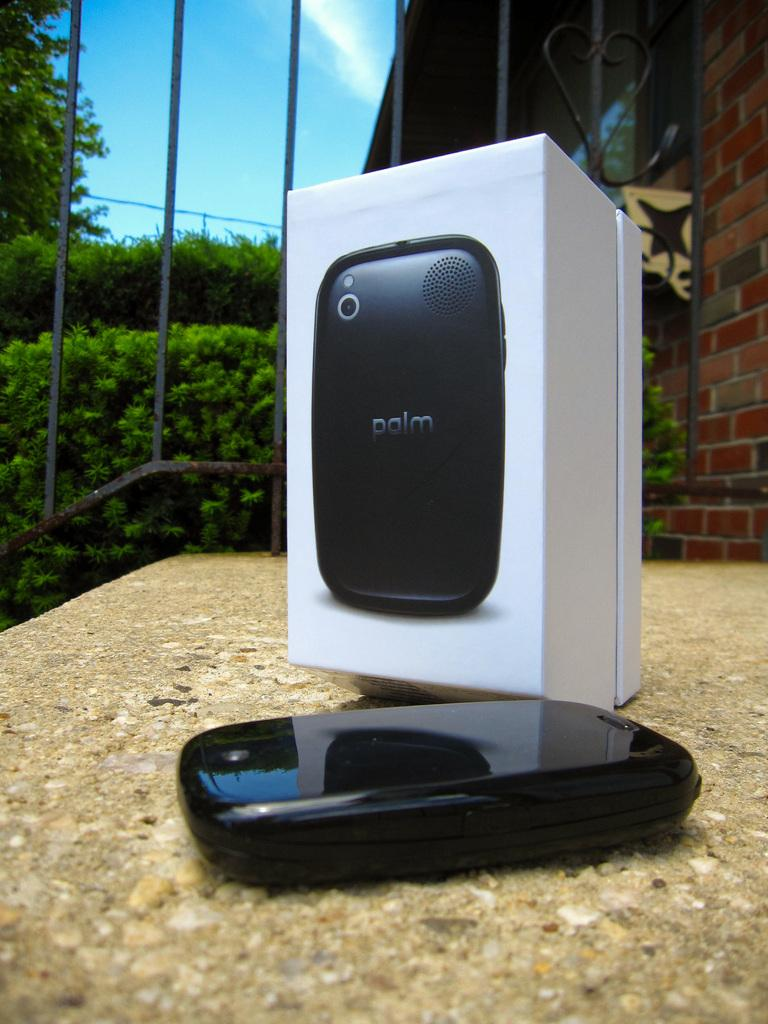Provide a one-sentence caption for the provided image. A black phone, marked palm, is laying in front of its box. 